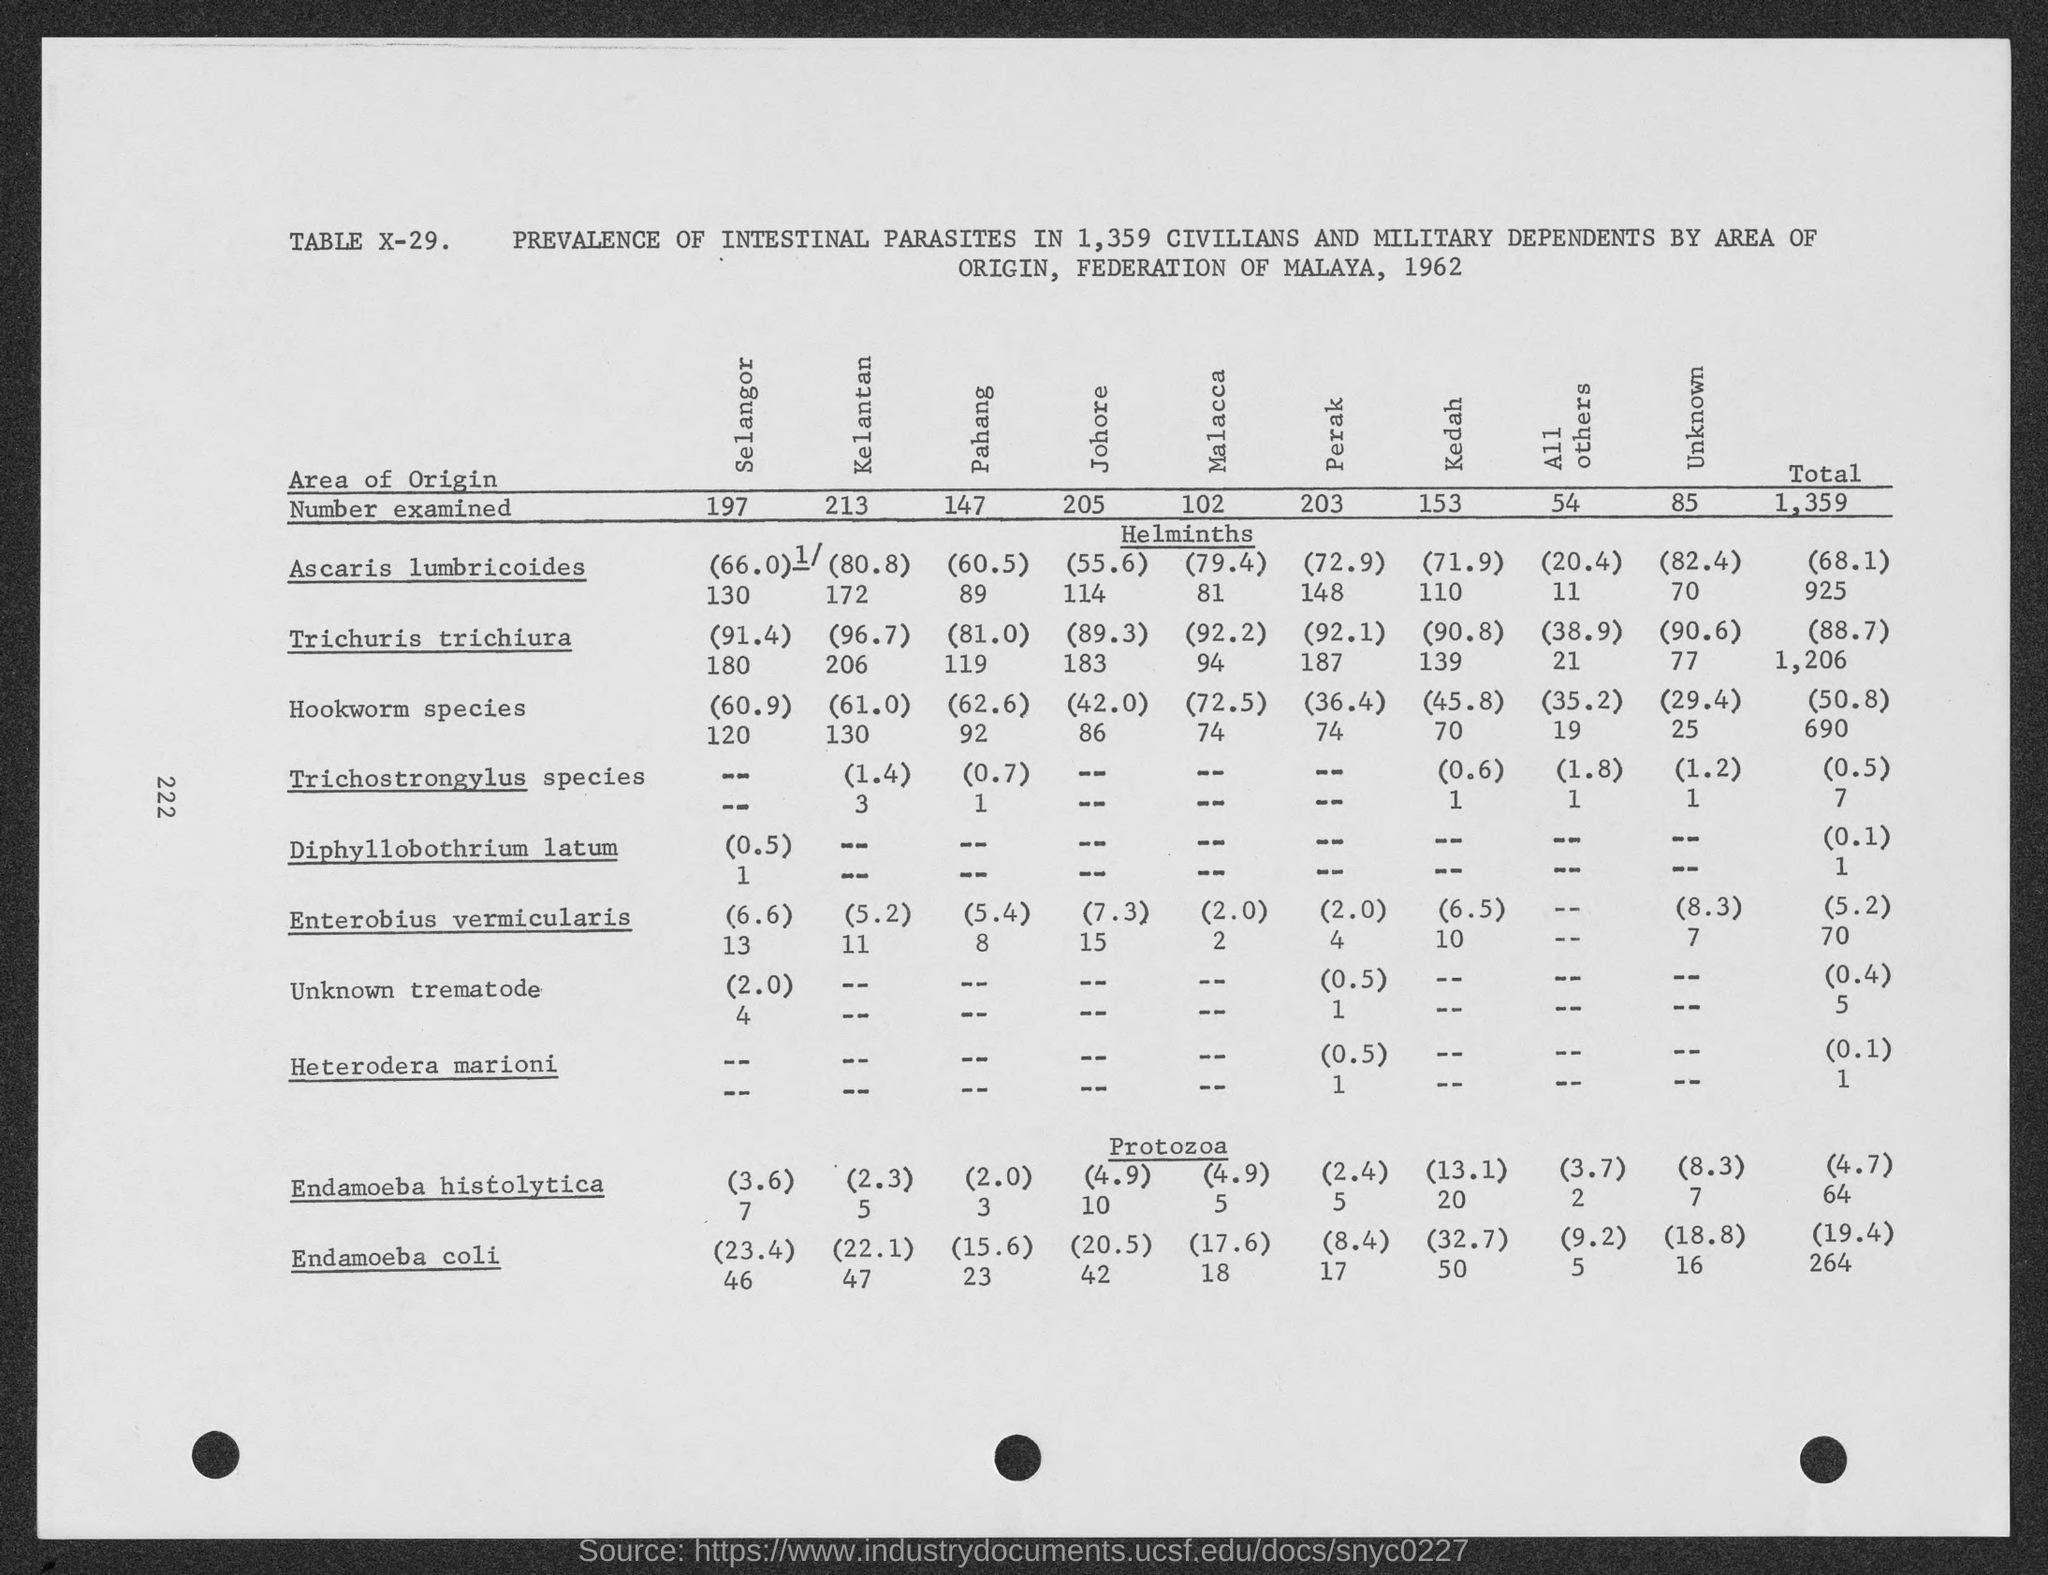What is the total number of persons examined?
Provide a succinct answer. 1,359. What is the page number?
Your answer should be very brief. 222. What is the table number?
Offer a terse response. X-29. What is the number of persons examined in Pahang?
Provide a succinct answer. 147. 